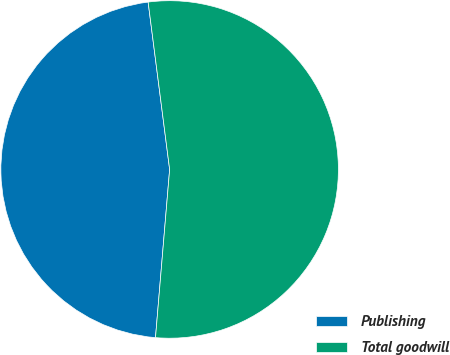Convert chart. <chart><loc_0><loc_0><loc_500><loc_500><pie_chart><fcel>Publishing<fcel>Total goodwill<nl><fcel>46.63%<fcel>53.37%<nl></chart> 